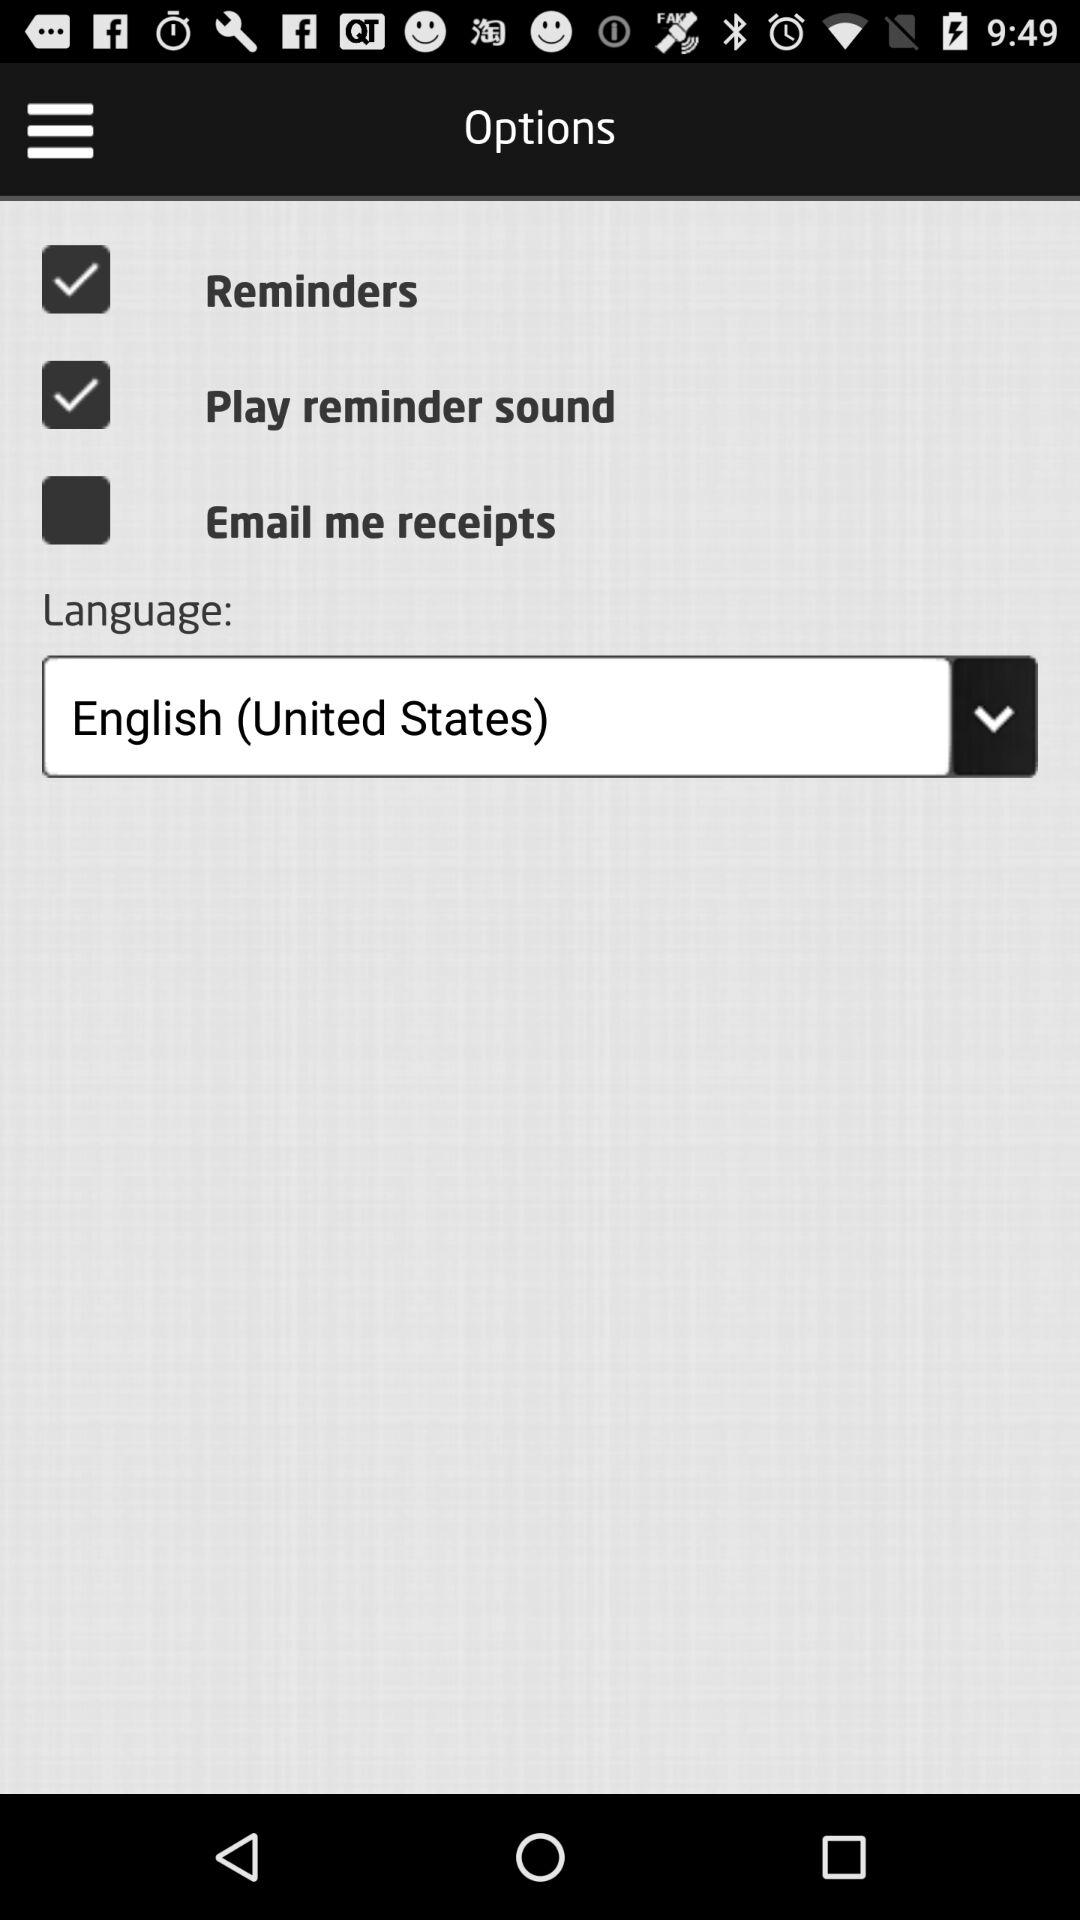Which option is not selected? The option that is not selected is "Email me receipts". 